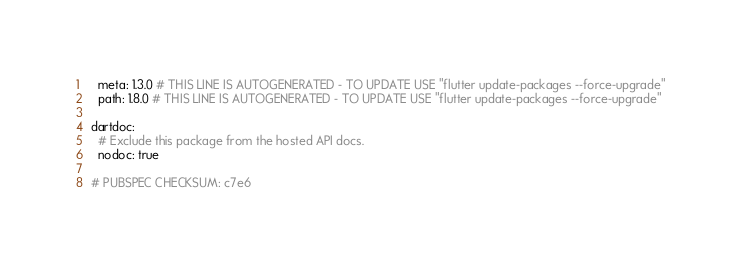<code> <loc_0><loc_0><loc_500><loc_500><_YAML_>
  meta: 1.3.0 # THIS LINE IS AUTOGENERATED - TO UPDATE USE "flutter update-packages --force-upgrade"
  path: 1.8.0 # THIS LINE IS AUTOGENERATED - TO UPDATE USE "flutter update-packages --force-upgrade"

dartdoc:
  # Exclude this package from the hosted API docs.
  nodoc: true

# PUBSPEC CHECKSUM: c7e6
</code> 